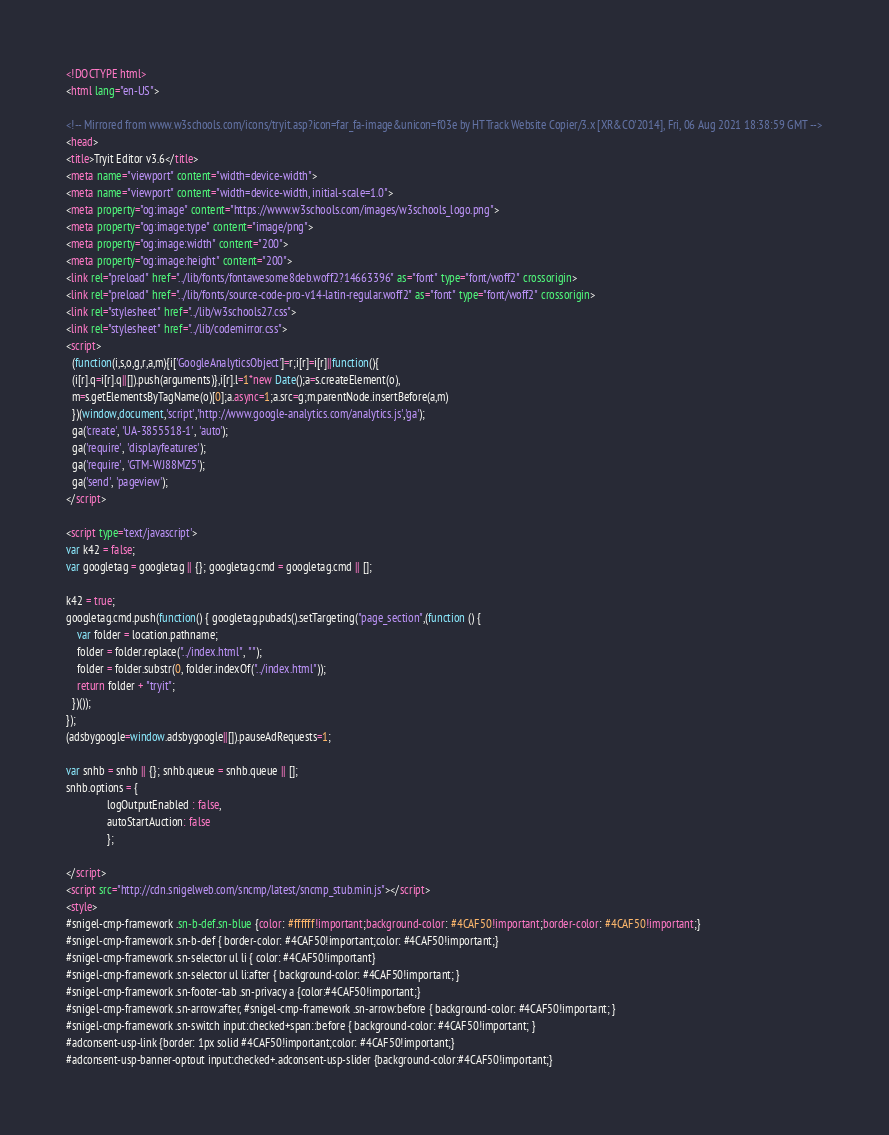Convert code to text. <code><loc_0><loc_0><loc_500><loc_500><_HTML_>
<!DOCTYPE html>
<html lang="en-US">

<!-- Mirrored from www.w3schools.com/icons/tryit.asp?icon=far_fa-image&unicon=f03e by HTTrack Website Copier/3.x [XR&CO'2014], Fri, 06 Aug 2021 18:38:59 GMT -->
<head>
<title>Tryit Editor v3.6</title>
<meta name="viewport" content="width=device-width">
<meta name="viewport" content="width=device-width, initial-scale=1.0">
<meta property="og:image" content="https://www.w3schools.com/images/w3schools_logo.png">
<meta property="og:image:type" content="image/png">
<meta property="og:image:width" content="200">
<meta property="og:image:height" content="200">
<link rel="preload" href="../lib/fonts/fontawesome8deb.woff2?14663396" as="font" type="font/woff2" crossorigin> 
<link rel="preload" href="../lib/fonts/source-code-pro-v14-latin-regular.woff2" as="font" type="font/woff2" crossorigin> 
<link rel="stylesheet" href="../lib/w3schools27.css">
<link rel="stylesheet" href="../lib/codemirror.css">
<script>
  (function(i,s,o,g,r,a,m){i['GoogleAnalyticsObject']=r;i[r]=i[r]||function(){
  (i[r].q=i[r].q||[]).push(arguments)},i[r].l=1*new Date();a=s.createElement(o),
  m=s.getElementsByTagName(o)[0];a.async=1;a.src=g;m.parentNode.insertBefore(a,m)
  })(window,document,'script','http://www.google-analytics.com/analytics.js','ga');
  ga('create', 'UA-3855518-1', 'auto');
  ga('require', 'displayfeatures');
  ga('require', 'GTM-WJ88MZ5');
  ga('send', 'pageview');
</script>

<script type='text/javascript'>
var k42 = false;
var googletag = googletag || {}; googletag.cmd = googletag.cmd || [];

k42 = true;
googletag.cmd.push(function() { googletag.pubads().setTargeting("page_section",(function () {
    var folder = location.pathname;
    folder = folder.replace("../index.html", "");
    folder = folder.substr(0, folder.indexOf("../index.html"));
    return folder + "tryit";
  })());
});  
(adsbygoogle=window.adsbygoogle||[]).pauseAdRequests=1;

var snhb = snhb || {}; snhb.queue = snhb.queue || [];
snhb.options = {
               logOutputEnabled : false,
               autoStartAuction: false
               };

</script>
<script src="http://cdn.snigelweb.com/sncmp/latest/sncmp_stub.min.js"></script>
<style>
#snigel-cmp-framework .sn-b-def.sn-blue {color: #ffffff!important;background-color: #4CAF50!important;border-color: #4CAF50!important;}
#snigel-cmp-framework .sn-b-def { border-color: #4CAF50!important;color: #4CAF50!important;}
#snigel-cmp-framework .sn-selector ul li { color: #4CAF50!important}
#snigel-cmp-framework .sn-selector ul li:after { background-color: #4CAF50!important; }
#snigel-cmp-framework .sn-footer-tab .sn-privacy a {color:#4CAF50!important;}
#snigel-cmp-framework .sn-arrow:after, #snigel-cmp-framework .sn-arrow:before { background-color: #4CAF50!important; }
#snigel-cmp-framework .sn-switch input:checked+span::before { background-color: #4CAF50!important; }
#adconsent-usp-link {border: 1px solid #4CAF50!important;color: #4CAF50!important;}
#adconsent-usp-banner-optout input:checked+.adconsent-usp-slider {background-color:#4CAF50!important;}</code> 